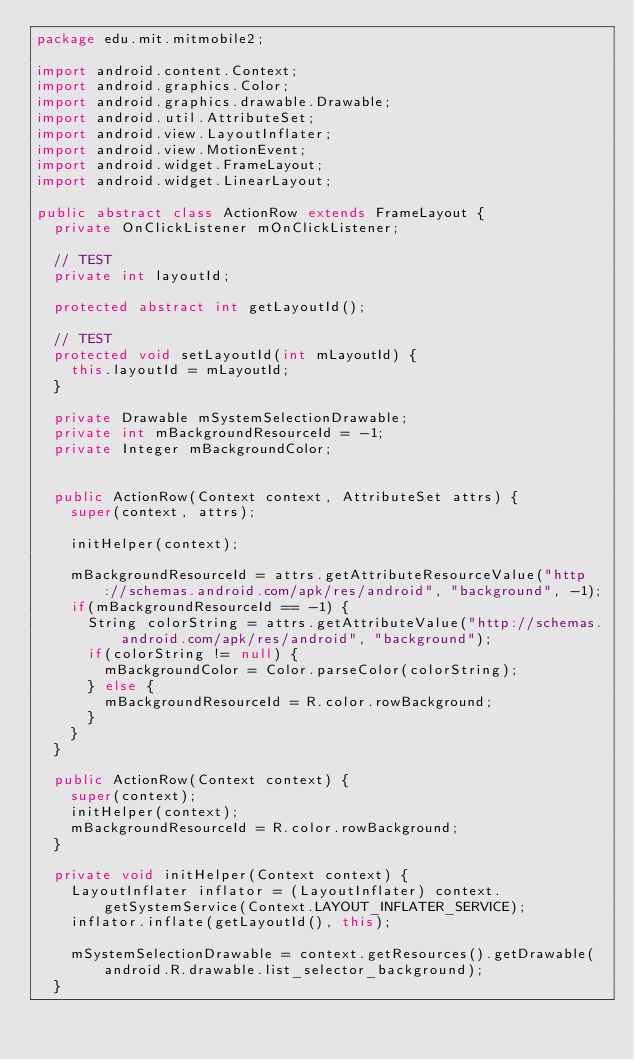<code> <loc_0><loc_0><loc_500><loc_500><_Java_>package edu.mit.mitmobile2;

import android.content.Context;
import android.graphics.Color;
import android.graphics.drawable.Drawable;
import android.util.AttributeSet;
import android.view.LayoutInflater;
import android.view.MotionEvent;
import android.widget.FrameLayout;
import android.widget.LinearLayout;

public abstract class ActionRow extends FrameLayout {	
	private OnClickListener mOnClickListener;

	// TEST
	private int layoutId;
	
	protected abstract int getLayoutId();

	// TEST
	protected void setLayoutId(int mLayoutId) {
		this.layoutId = mLayoutId;
	}
	
	private Drawable mSystemSelectionDrawable;
	private int mBackgroundResourceId = -1;
	private Integer mBackgroundColor;
	
	
	public ActionRow(Context context, AttributeSet attrs) {
		super(context, attrs);
		
		initHelper(context);

		mBackgroundResourceId = attrs.getAttributeResourceValue("http://schemas.android.com/apk/res/android", "background", -1);
		if(mBackgroundResourceId == -1) {
			String colorString = attrs.getAttributeValue("http://schemas.android.com/apk/res/android", "background");
			if(colorString != null) {
				mBackgroundColor = Color.parseColor(colorString);
			} else {
				mBackgroundResourceId = R.color.rowBackground;
			}
		}
	}

	public ActionRow(Context context) {
		super(context);
		initHelper(context);
		mBackgroundResourceId = R.color.rowBackground;
	}
	
	private void initHelper(Context context) {
		LayoutInflater inflator = (LayoutInflater) context.getSystemService(Context.LAYOUT_INFLATER_SERVICE);
		inflator.inflate(getLayoutId(), this);
		
		mSystemSelectionDrawable = context.getResources().getDrawable(android.R.drawable.list_selector_background);
	}
	</code> 